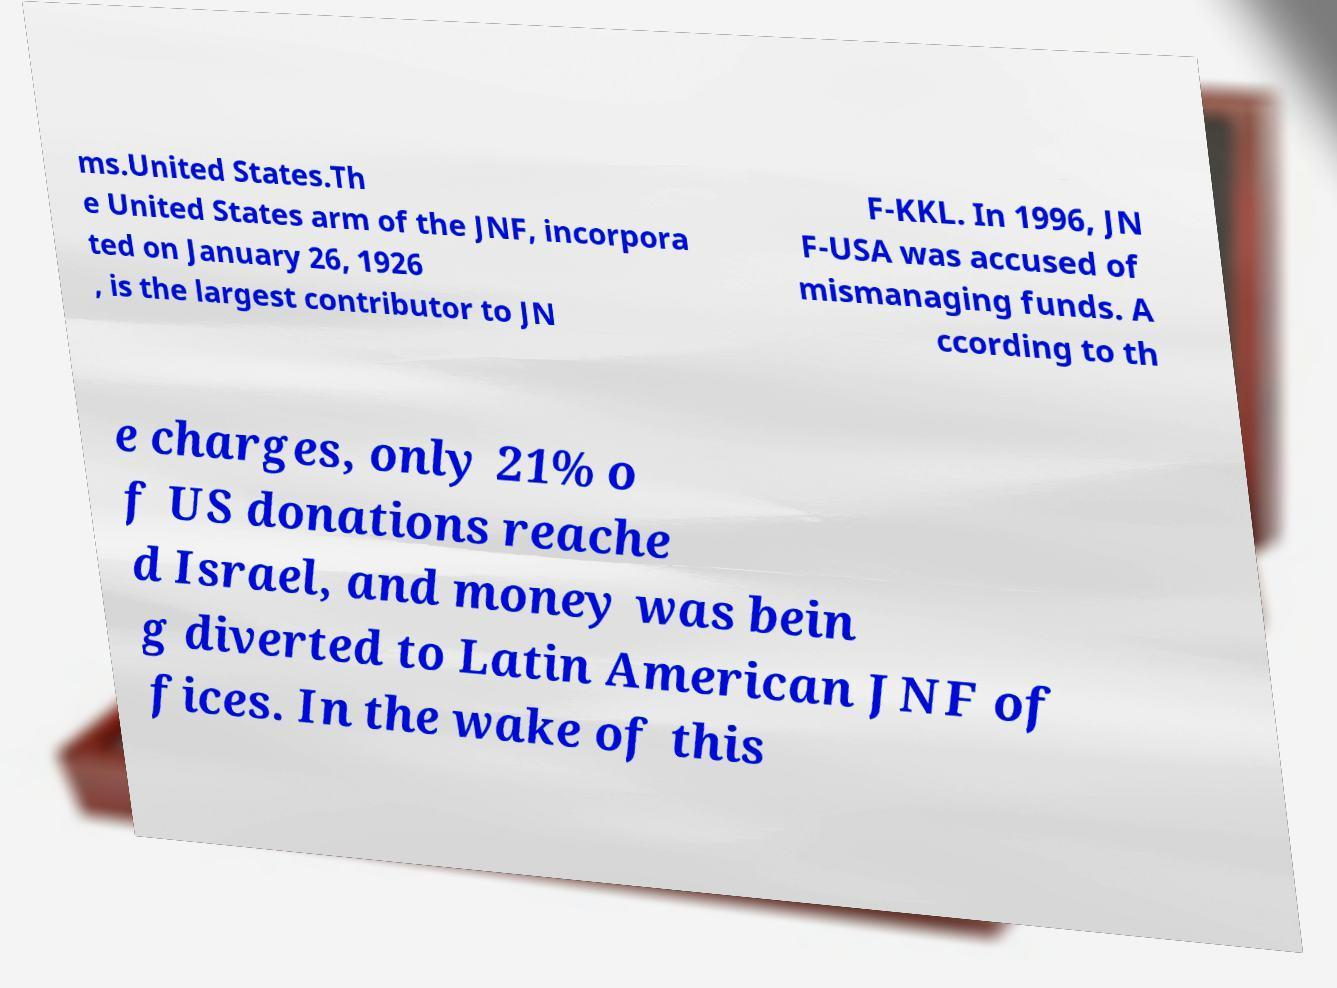What messages or text are displayed in this image? I need them in a readable, typed format. ms.United States.Th e United States arm of the JNF, incorpora ted on January 26, 1926 , is the largest contributor to JN F-KKL. In 1996, JN F-USA was accused of mismanaging funds. A ccording to th e charges, only 21% o f US donations reache d Israel, and money was bein g diverted to Latin American JNF of fices. In the wake of this 